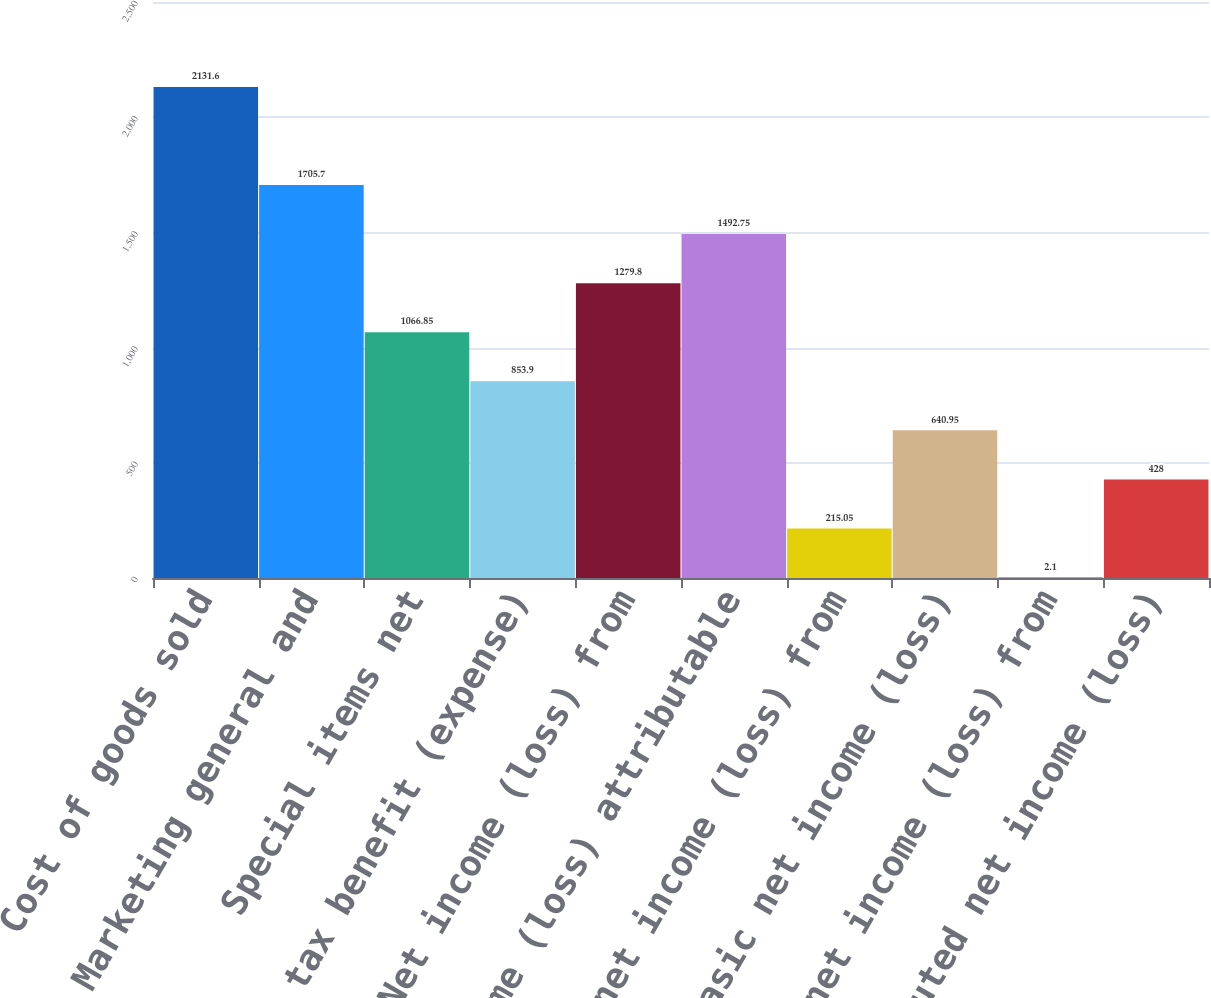Convert chart. <chart><loc_0><loc_0><loc_500><loc_500><bar_chart><fcel>Cost of goods sold<fcel>Marketing general and<fcel>Special items net<fcel>Income tax benefit (expense)<fcel>Net income (loss) from<fcel>Net income (loss) attributable<fcel>Basic net income (loss) from<fcel>Basic net income (loss)<fcel>Diluted net income (loss) from<fcel>Diluted net income (loss)<nl><fcel>2131.6<fcel>1705.7<fcel>1066.85<fcel>853.9<fcel>1279.8<fcel>1492.75<fcel>215.05<fcel>640.95<fcel>2.1<fcel>428<nl></chart> 